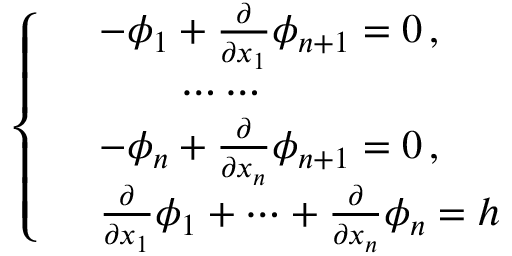<formula> <loc_0><loc_0><loc_500><loc_500>\left \{ \begin{array} { r l } & { - \phi _ { 1 } + \frac { \partial } { \partial x _ { 1 } } \phi _ { n + 1 } = 0 \, , } \\ & { \quad \cdots \cdots } \\ & { - \phi _ { n } + \frac { \partial } { \partial x _ { n } } \phi _ { n + 1 } = 0 \, , } \\ & { \frac { \partial } { \partial x _ { 1 } } \phi _ { 1 } + \cdots + \frac { \partial } { \partial x _ { n } } \phi _ { n } = h } \end{array}</formula> 